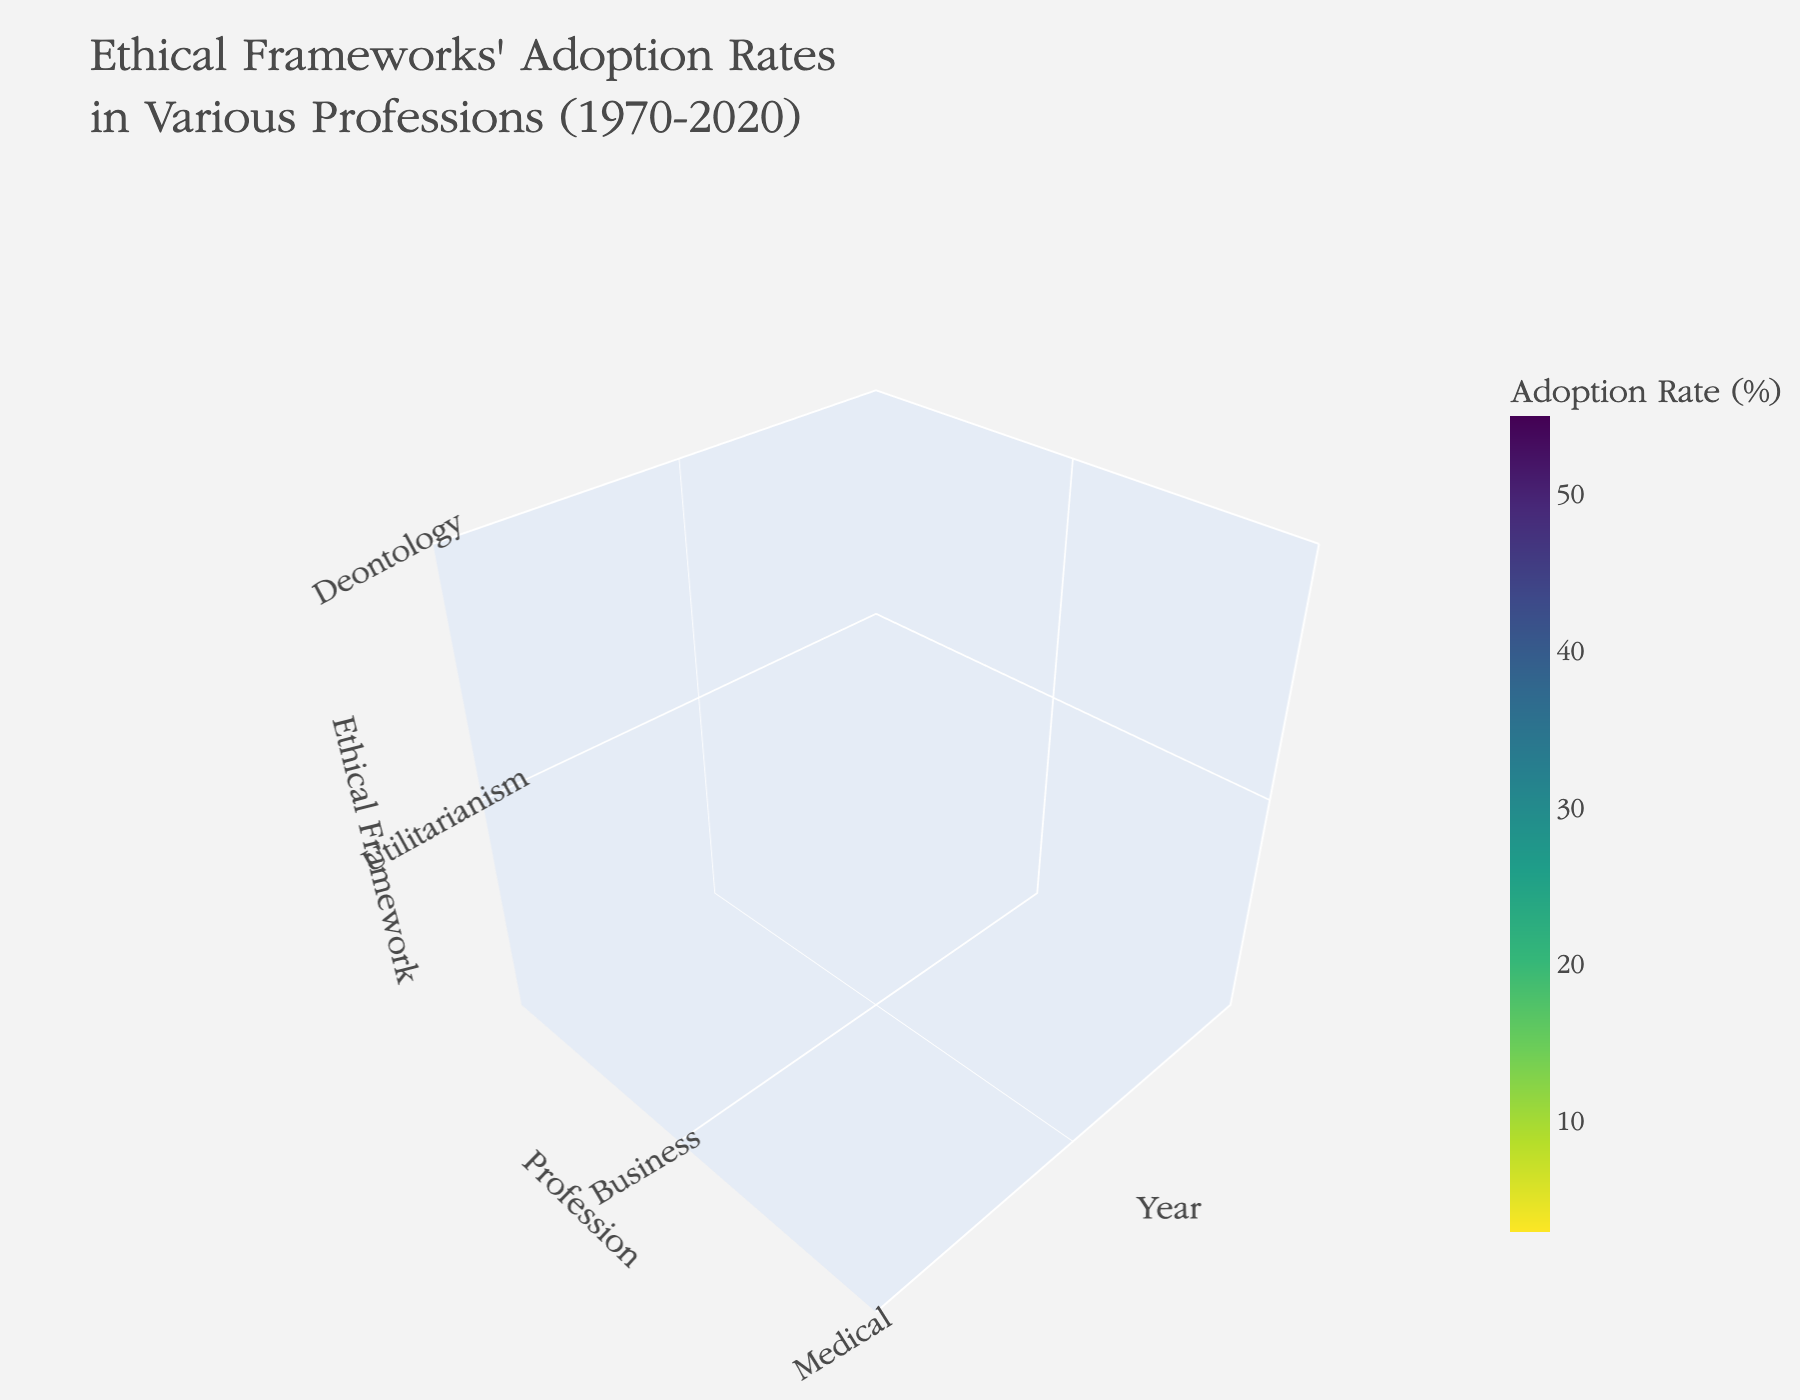What's the title of the plot? The title is displayed prominently at the top of the plot. According to the input data, it is "Ethical Frameworks' Adoption Rates in Various Professions (1970-2020)."
Answer: Ethical Frameworks' Adoption Rates in Various Professions (1970-2020) Which profession shows the highest adoption rate for Deontology in 2020? To answer this, locate the year 2020 on the x-axis, then identify the data point where Deontology (z-axis) intersects with each profession (y-axis). The Legal profession shows the highest adoption rate for Deontology in 2020.
Answer: Legal What was the adoption rate of Utilitarianism in the Medical profession in 1970? Identify the year 1970 on the x-axis and locate the Medical profession on the y-axis. Trace to the data point for Utilitarianism on the z-axis. The adoption rate is found on the color-coded scale. The Medical profession had a 15% adoption rate for Utilitarianism in 1970.
Answer: 15% Compare the adoption rates of Virtue Ethics in the Business profession between 1970 and 2020. First, locate the Business profession on the y-axis, then compare the adoption rates for Virtue Ethics (z-axis) in the years 1970 and 2020 on the x-axis. In 1970, the rate was 3%, and in 2020, it was 25%, indicating an increase.
Answer: 3% in 1970, 25% in 2020 What is the average adoption rate for Utilitarianism across all professions in 1995? Identify the year 1995 on the x-axis. For each profession (y-axis), note the adoption rate for Utilitarianism (z-axis). Sum these rates: 25 (Business) + 30 (Medical) + 28 (Legal) = 83. Divide by the number of professions (3). The average adoption rate is approximately 27.67%.
Answer: 27.67% Which ethical framework had the lowest adoption rate in the Legal profession in 1995? Locate the Legal profession on the y-axis and the year 1995 on the x-axis. Compare the adoption rates for all three ethical frameworks (z-axis). Virtue Ethics has the lowest adoption rate at 15%.
Answer: Virtue Ethics How has the adoption rate of Deontology in the Medical profession changed from 1970 to 2020? Identify the Medical profession on the y-axis, then compare the adoption rates for Deontology (z-axis) in the years 1970 and 2020 on the x-axis. In 1970, the rate was 20%, and in 2020, it was 50%, showing an increase.
Answer: Increased from 20% to 50% 